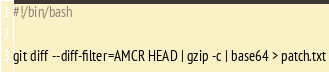<code> <loc_0><loc_0><loc_500><loc_500><_Bash_>#!/bin/bash

git diff --diff-filter=AMCR HEAD | gzip -c | base64 > patch.txt
</code> 